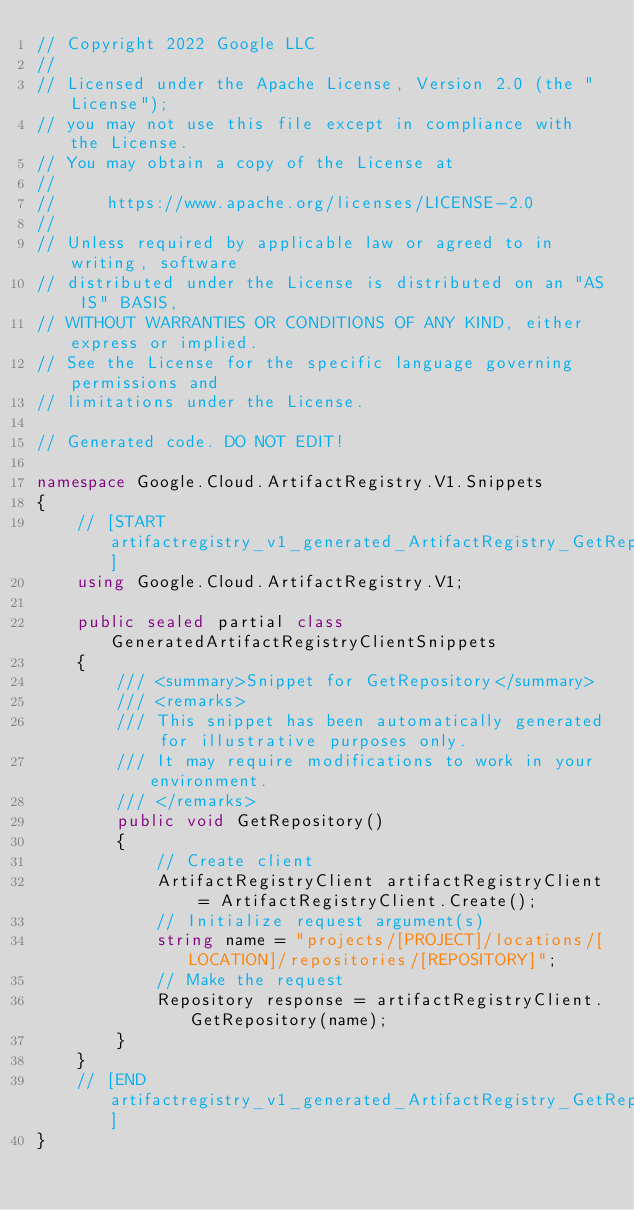<code> <loc_0><loc_0><loc_500><loc_500><_C#_>// Copyright 2022 Google LLC
//
// Licensed under the Apache License, Version 2.0 (the "License");
// you may not use this file except in compliance with the License.
// You may obtain a copy of the License at
//
//     https://www.apache.org/licenses/LICENSE-2.0
//
// Unless required by applicable law or agreed to in writing, software
// distributed under the License is distributed on an "AS IS" BASIS,
// WITHOUT WARRANTIES OR CONDITIONS OF ANY KIND, either express or implied.
// See the License for the specific language governing permissions and
// limitations under the License.

// Generated code. DO NOT EDIT!

namespace Google.Cloud.ArtifactRegistry.V1.Snippets
{
    // [START artifactregistry_v1_generated_ArtifactRegistry_GetRepository_sync_flattened]
    using Google.Cloud.ArtifactRegistry.V1;

    public sealed partial class GeneratedArtifactRegistryClientSnippets
    {
        /// <summary>Snippet for GetRepository</summary>
        /// <remarks>
        /// This snippet has been automatically generated for illustrative purposes only.
        /// It may require modifications to work in your environment.
        /// </remarks>
        public void GetRepository()
        {
            // Create client
            ArtifactRegistryClient artifactRegistryClient = ArtifactRegistryClient.Create();
            // Initialize request argument(s)
            string name = "projects/[PROJECT]/locations/[LOCATION]/repositories/[REPOSITORY]";
            // Make the request
            Repository response = artifactRegistryClient.GetRepository(name);
        }
    }
    // [END artifactregistry_v1_generated_ArtifactRegistry_GetRepository_sync_flattened]
}
</code> 